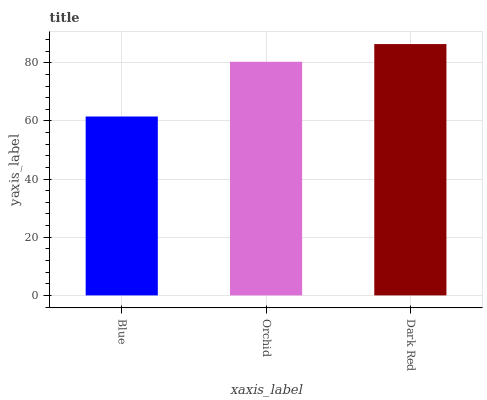Is Orchid the minimum?
Answer yes or no. No. Is Orchid the maximum?
Answer yes or no. No. Is Orchid greater than Blue?
Answer yes or no. Yes. Is Blue less than Orchid?
Answer yes or no. Yes. Is Blue greater than Orchid?
Answer yes or no. No. Is Orchid less than Blue?
Answer yes or no. No. Is Orchid the high median?
Answer yes or no. Yes. Is Orchid the low median?
Answer yes or no. Yes. Is Dark Red the high median?
Answer yes or no. No. Is Dark Red the low median?
Answer yes or no. No. 